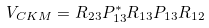<formula> <loc_0><loc_0><loc_500><loc_500>V _ { C K M } = R _ { 2 3 } P _ { 1 3 } ^ { \ast } R _ { 1 3 } P _ { 1 3 } R _ { 1 2 }</formula> 